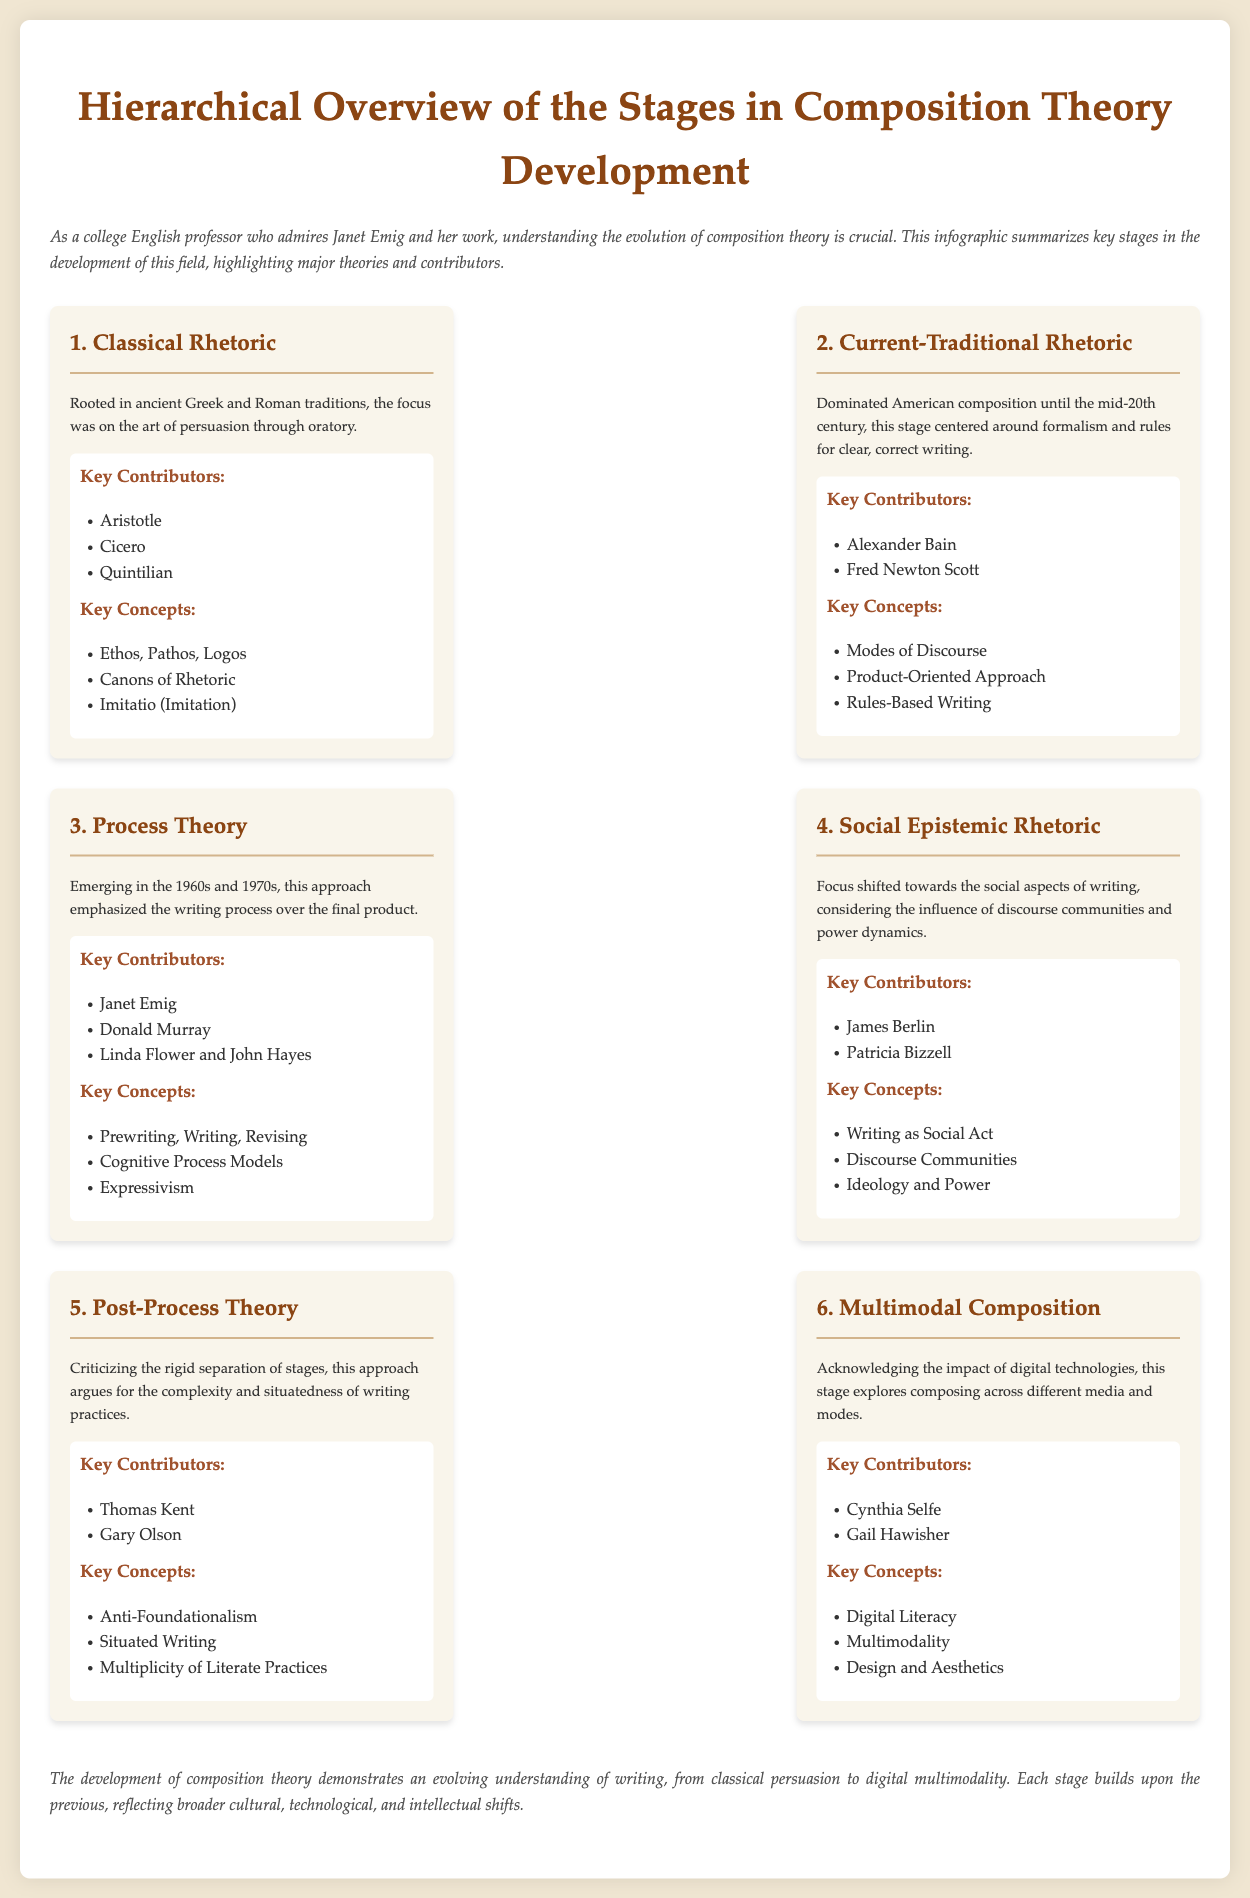What is the first stage in composition theory development? The title of the first stage listed in the infographic is "Classical Rhetoric."
Answer: Classical Rhetoric Who contributed to the Social Epistemic Rhetoric stage? The key contributors mentioned for this stage include James Berlin and Patricia Bizzell.
Answer: James Berlin, Patricia Bizzell What concept is associated with Post-Process Theory? The key concept highlighted for Post-Process Theory is "Anti-Foundationalism."
Answer: Anti-Foundationalism How many key contributors are listed for Process Theory? The number of key contributors mentioned for Process Theory is three.
Answer: Three What is the primary focus of the Multimodal Composition stage? The infographic states the focus of this stage is "composing across different media and modes."
Answer: Composing across different media and modes Which stage emphasizes the writing process over the final product? The stage that emphasizes the writing process is called "Process Theory."
Answer: Process Theory What philosophical approach is criticized in Post-Process Theory? The approach criticized in Post-Process Theory is the "rigid separation of stages."
Answer: Rigid separation of stages In which decade did Process Theory emerge? Process Theory emerged in the 1960s and 1970s.
Answer: 1960s and 1970s 